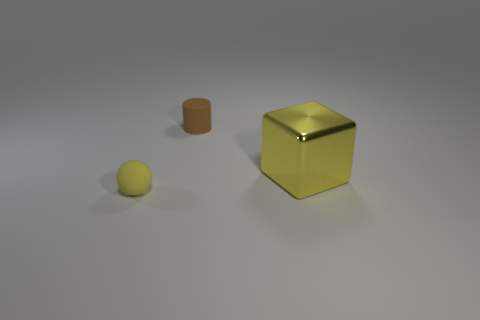There is a thing that is the same color as the large shiny block; what size is it? The item that shares the same color as the large shiny block is small in size, specifically, it appears to be a small yellow ball. 